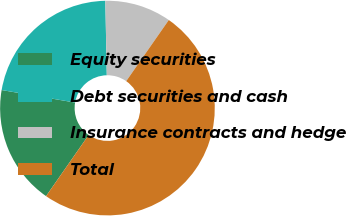Convert chart. <chart><loc_0><loc_0><loc_500><loc_500><pie_chart><fcel>Equity securities<fcel>Debt securities and cash<fcel>Insurance contracts and hedge<fcel>Total<nl><fcel>18.0%<fcel>22.0%<fcel>10.0%<fcel>50.0%<nl></chart> 